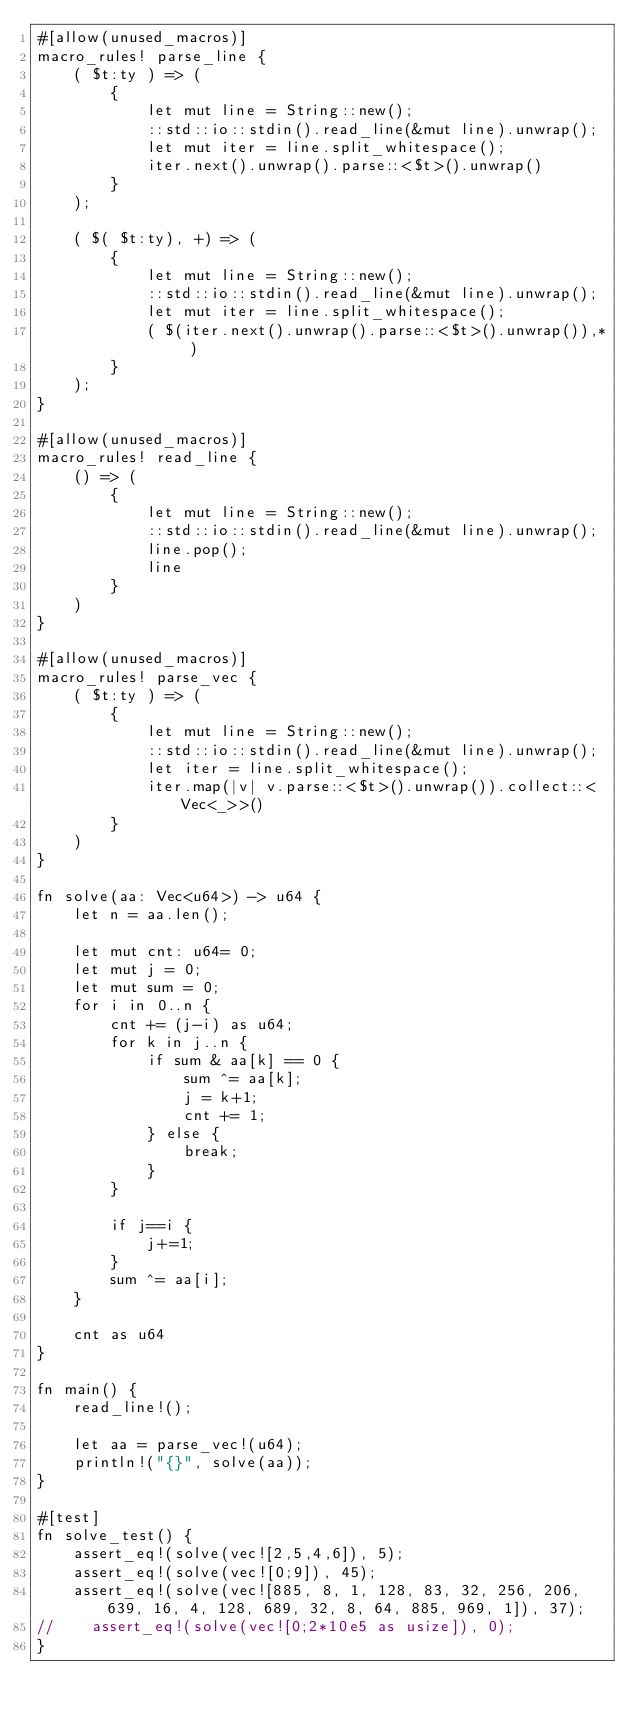<code> <loc_0><loc_0><loc_500><loc_500><_Rust_>#[allow(unused_macros)]
macro_rules! parse_line {
    ( $t:ty ) => (
        {
            let mut line = String::new();
            ::std::io::stdin().read_line(&mut line).unwrap();
            let mut iter = line.split_whitespace();
            iter.next().unwrap().parse::<$t>().unwrap()
        }
    );

    ( $( $t:ty), +) => (
        {
            let mut line = String::new();
            ::std::io::stdin().read_line(&mut line).unwrap();
            let mut iter = line.split_whitespace();
            ( $(iter.next().unwrap().parse::<$t>().unwrap()),* )
        }
    );
}

#[allow(unused_macros)]
macro_rules! read_line {
    () => (
        {
            let mut line = String::new();
            ::std::io::stdin().read_line(&mut line).unwrap();
            line.pop();
            line
        }
    )
}

#[allow(unused_macros)]
macro_rules! parse_vec {
    ( $t:ty ) => (
        {
            let mut line = String::new();
            ::std::io::stdin().read_line(&mut line).unwrap();
            let iter = line.split_whitespace();
            iter.map(|v| v.parse::<$t>().unwrap()).collect::<Vec<_>>()
        }
    )
}

fn solve(aa: Vec<u64>) -> u64 {
    let n = aa.len();

    let mut cnt: u64= 0;
    let mut j = 0;
    let mut sum = 0;
    for i in 0..n {
        cnt += (j-i) as u64;
        for k in j..n {
            if sum & aa[k] == 0 {
                sum ^= aa[k];
                j = k+1;
                cnt += 1;
            } else {
                break;
            }
        }

        if j==i {
            j+=1;
        }
        sum ^= aa[i];
    }

    cnt as u64
}

fn main() {
    read_line!();

    let aa = parse_vec!(u64);
    println!("{}", solve(aa));
}

#[test]
fn solve_test() {
    assert_eq!(solve(vec![2,5,4,6]), 5);
    assert_eq!(solve(vec![0;9]), 45);
    assert_eq!(solve(vec![885, 8, 1, 128, 83, 32, 256, 206, 639, 16, 4, 128, 689, 32, 8, 64, 885, 969, 1]), 37);
//    assert_eq!(solve(vec![0;2*10e5 as usize]), 0);
}
</code> 